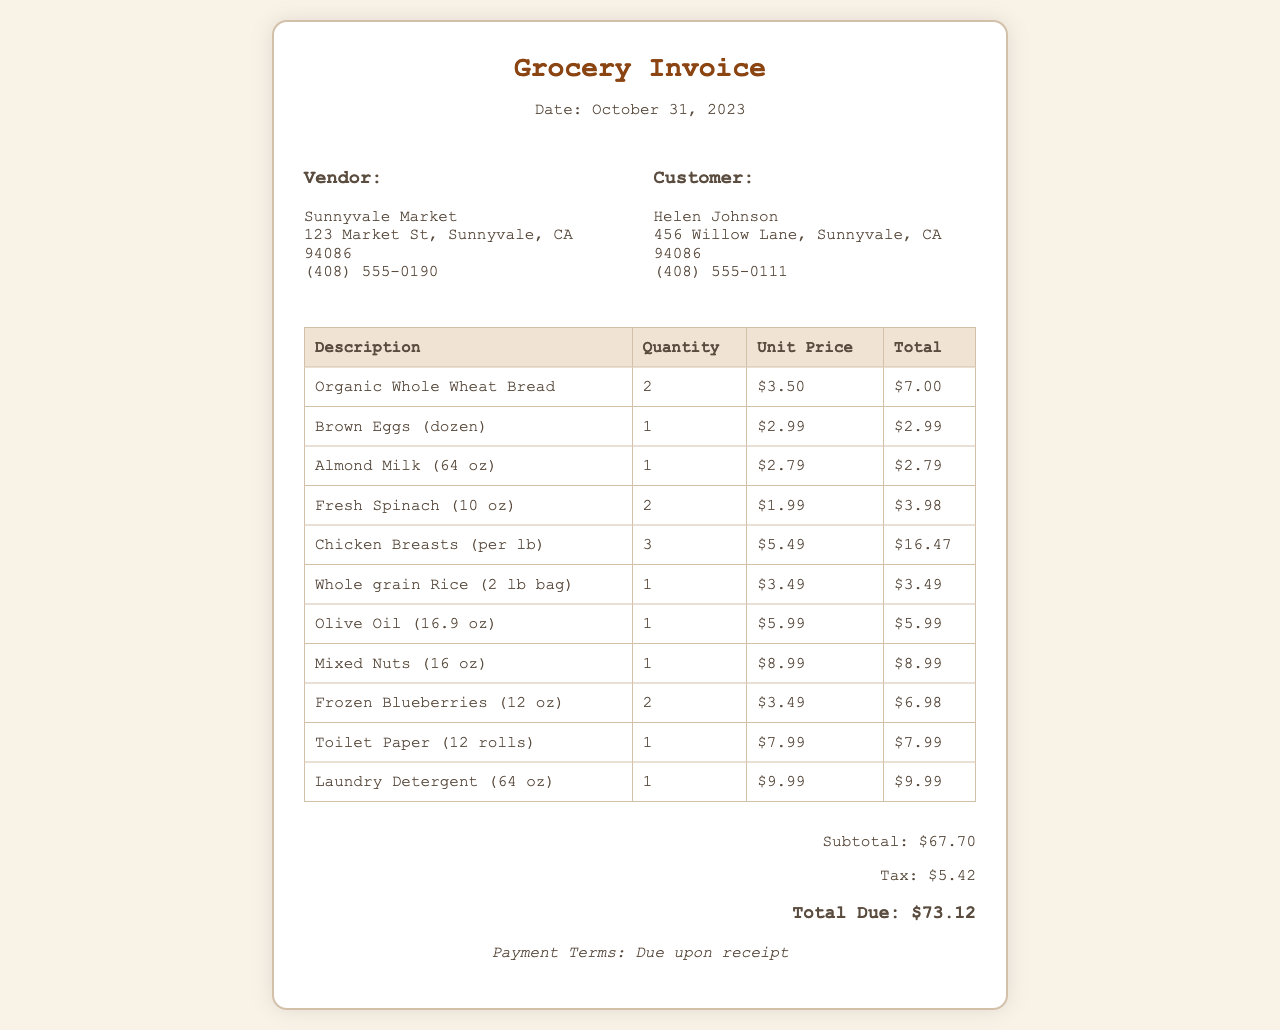What is the date of the invoice? The date is specified at the top of the invoice.
Answer: October 31, 2023 Who is the vendor? The vendor's information is detailed in the invoice header.
Answer: Sunnyvale Market What is the total due? The total amount due is listed at the bottom of the invoice.
Answer: $73.12 How many items of Chicken Breasts were purchased? The quantity for Chicken Breasts can be found in the itemized list.
Answer: 3 What is the unit price of Organic Whole Wheat Bread? The unit price is shown next to the respective item in the invoice.
Answer: $3.50 What is the subtotal amount before tax? The subtotal is provided in the total section of the invoice.
Answer: $67.70 What is the total tax amount? The tax figure is included in the total section of the invoice.
Answer: $5.42 What items are listed as household supplies? Household supplies include items purchased that are not food.
Answer: Toilet Paper, Laundry Detergent What is the quantity of Frozen Blueberries purchased? The quantity is reflected in the itemized section of the invoice.
Answer: 2 What are the payment terms stated in the invoice? The payment terms are provided at the bottom of the document.
Answer: Due upon receipt 